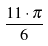Convert formula to latex. <formula><loc_0><loc_0><loc_500><loc_500>\frac { 1 1 \cdot \pi } { 6 }</formula> 